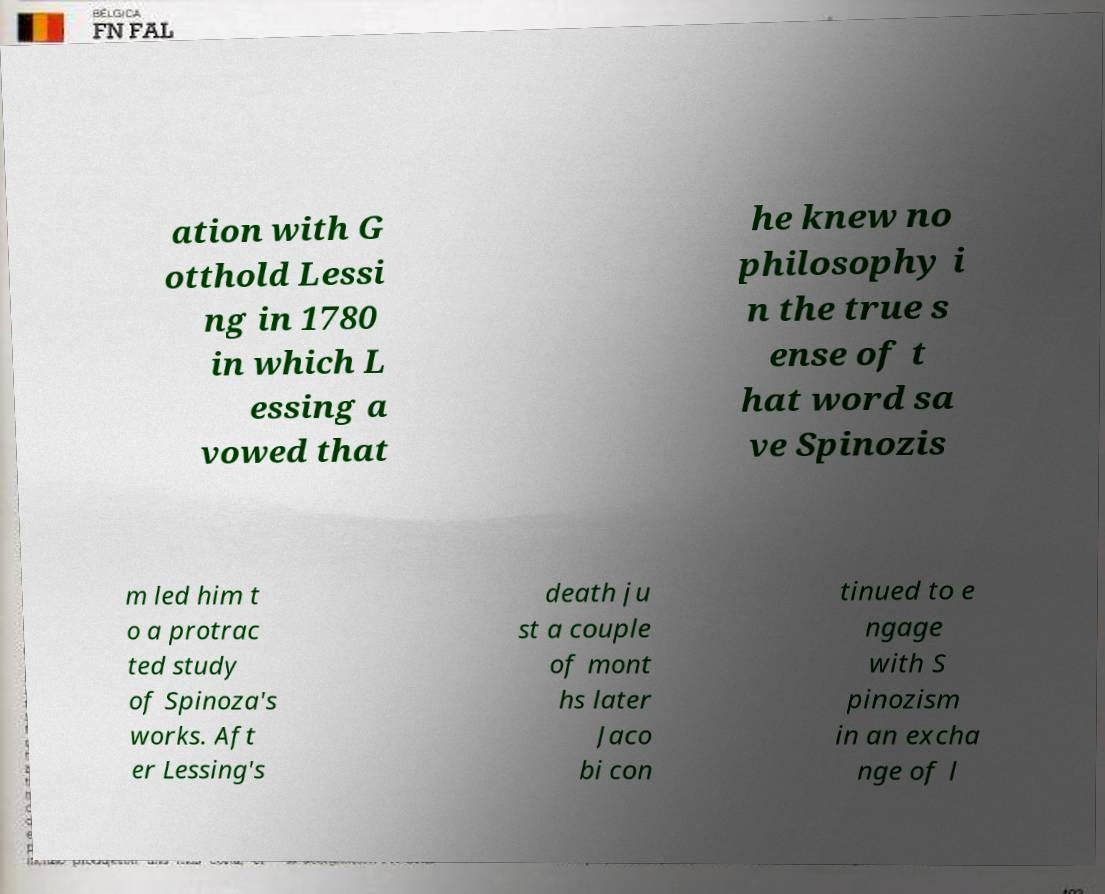There's text embedded in this image that I need extracted. Can you transcribe it verbatim? ation with G otthold Lessi ng in 1780 in which L essing a vowed that he knew no philosophy i n the true s ense of t hat word sa ve Spinozis m led him t o a protrac ted study of Spinoza's works. Aft er Lessing's death ju st a couple of mont hs later Jaco bi con tinued to e ngage with S pinozism in an excha nge of l 